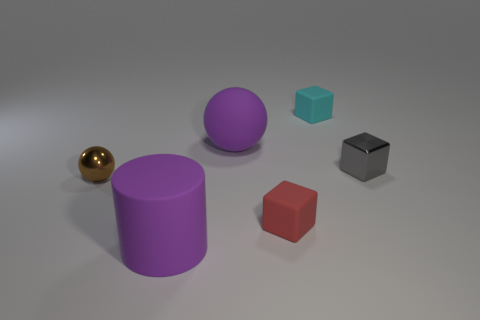Can you describe the texture and lighting conditions of the scene? The objects in the scene appear to have a smooth, matte finish with slightly reflective surfaces, indicating a diffuse lighting condition. Shadows are soft and subdued, suggesting an even light source without any harsh direct lighting. 